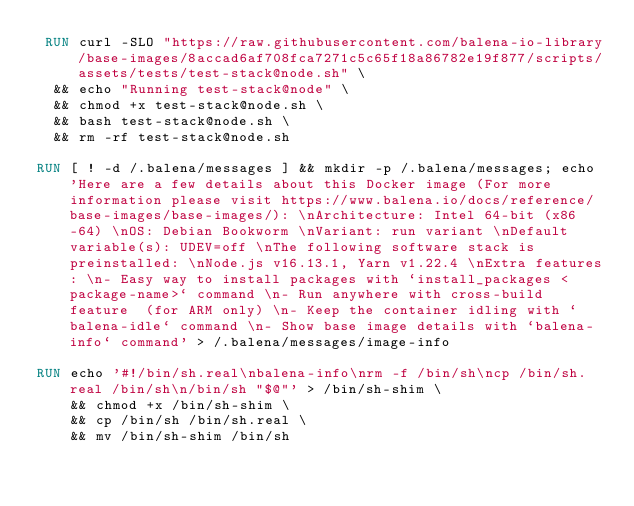Convert code to text. <code><loc_0><loc_0><loc_500><loc_500><_Dockerfile_> RUN curl -SLO "https://raw.githubusercontent.com/balena-io-library/base-images/8accad6af708fca7271c5c65f18a86782e19f877/scripts/assets/tests/test-stack@node.sh" \
  && echo "Running test-stack@node" \
  && chmod +x test-stack@node.sh \
  && bash test-stack@node.sh \
  && rm -rf test-stack@node.sh 

RUN [ ! -d /.balena/messages ] && mkdir -p /.balena/messages; echo 'Here are a few details about this Docker image (For more information please visit https://www.balena.io/docs/reference/base-images/base-images/): \nArchitecture: Intel 64-bit (x86-64) \nOS: Debian Bookworm \nVariant: run variant \nDefault variable(s): UDEV=off \nThe following software stack is preinstalled: \nNode.js v16.13.1, Yarn v1.22.4 \nExtra features: \n- Easy way to install packages with `install_packages <package-name>` command \n- Run anywhere with cross-build feature  (for ARM only) \n- Keep the container idling with `balena-idle` command \n- Show base image details with `balena-info` command' > /.balena/messages/image-info

RUN echo '#!/bin/sh.real\nbalena-info\nrm -f /bin/sh\ncp /bin/sh.real /bin/sh\n/bin/sh "$@"' > /bin/sh-shim \
	&& chmod +x /bin/sh-shim \
	&& cp /bin/sh /bin/sh.real \
	&& mv /bin/sh-shim /bin/sh</code> 